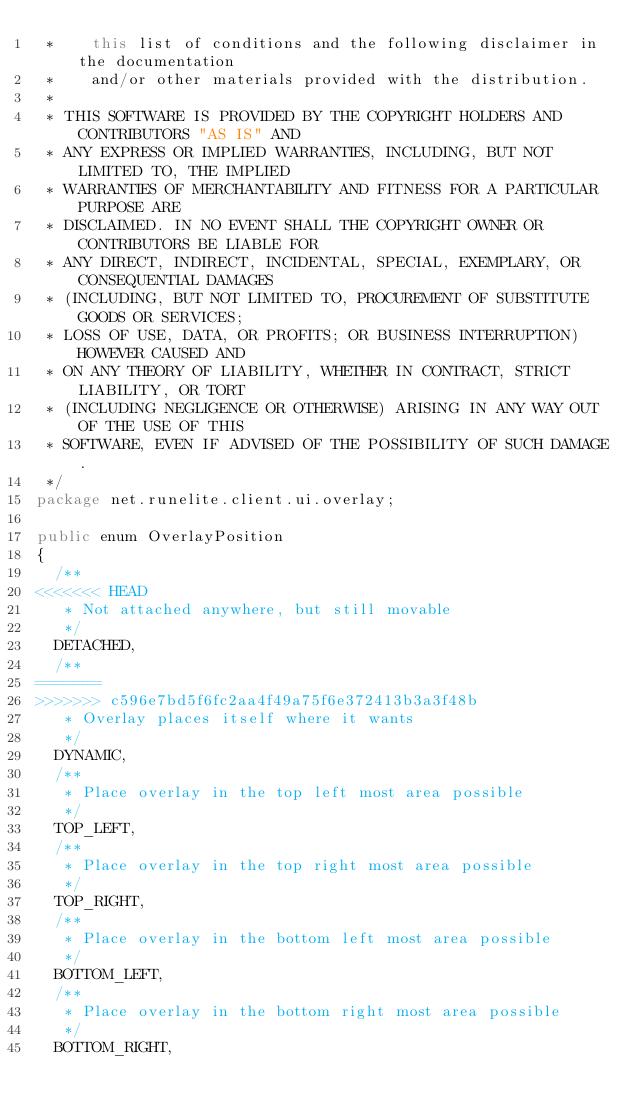Convert code to text. <code><loc_0><loc_0><loc_500><loc_500><_Java_> *    this list of conditions and the following disclaimer in the documentation
 *    and/or other materials provided with the distribution.
 *
 * THIS SOFTWARE IS PROVIDED BY THE COPYRIGHT HOLDERS AND CONTRIBUTORS "AS IS" AND
 * ANY EXPRESS OR IMPLIED WARRANTIES, INCLUDING, BUT NOT LIMITED TO, THE IMPLIED
 * WARRANTIES OF MERCHANTABILITY AND FITNESS FOR A PARTICULAR PURPOSE ARE
 * DISCLAIMED. IN NO EVENT SHALL THE COPYRIGHT OWNER OR CONTRIBUTORS BE LIABLE FOR
 * ANY DIRECT, INDIRECT, INCIDENTAL, SPECIAL, EXEMPLARY, OR CONSEQUENTIAL DAMAGES
 * (INCLUDING, BUT NOT LIMITED TO, PROCUREMENT OF SUBSTITUTE GOODS OR SERVICES;
 * LOSS OF USE, DATA, OR PROFITS; OR BUSINESS INTERRUPTION) HOWEVER CAUSED AND
 * ON ANY THEORY OF LIABILITY, WHETHER IN CONTRACT, STRICT LIABILITY, OR TORT
 * (INCLUDING NEGLIGENCE OR OTHERWISE) ARISING IN ANY WAY OUT OF THE USE OF THIS
 * SOFTWARE, EVEN IF ADVISED OF THE POSSIBILITY OF SUCH DAMAGE.
 */
package net.runelite.client.ui.overlay;

public enum OverlayPosition
{
	/**
<<<<<<< HEAD
	 * Not attached anywhere, but still movable
	 */
	DETACHED,
	/**
=======
>>>>>>> c596e7bd5f6fc2aa4f49a75f6e372413b3a3f48b
	 * Overlay places itself where it wants
	 */
	DYNAMIC,
	/**
	 * Place overlay in the top left most area possible
	 */
	TOP_LEFT,
	/**
	 * Place overlay in the top right most area possible
	 */
	TOP_RIGHT,
	/**
	 * Place overlay in the bottom left most area possible
	 */
	BOTTOM_LEFT,
	/**
	 * Place overlay in the bottom right most area possible
	 */
	BOTTOM_RIGHT,</code> 